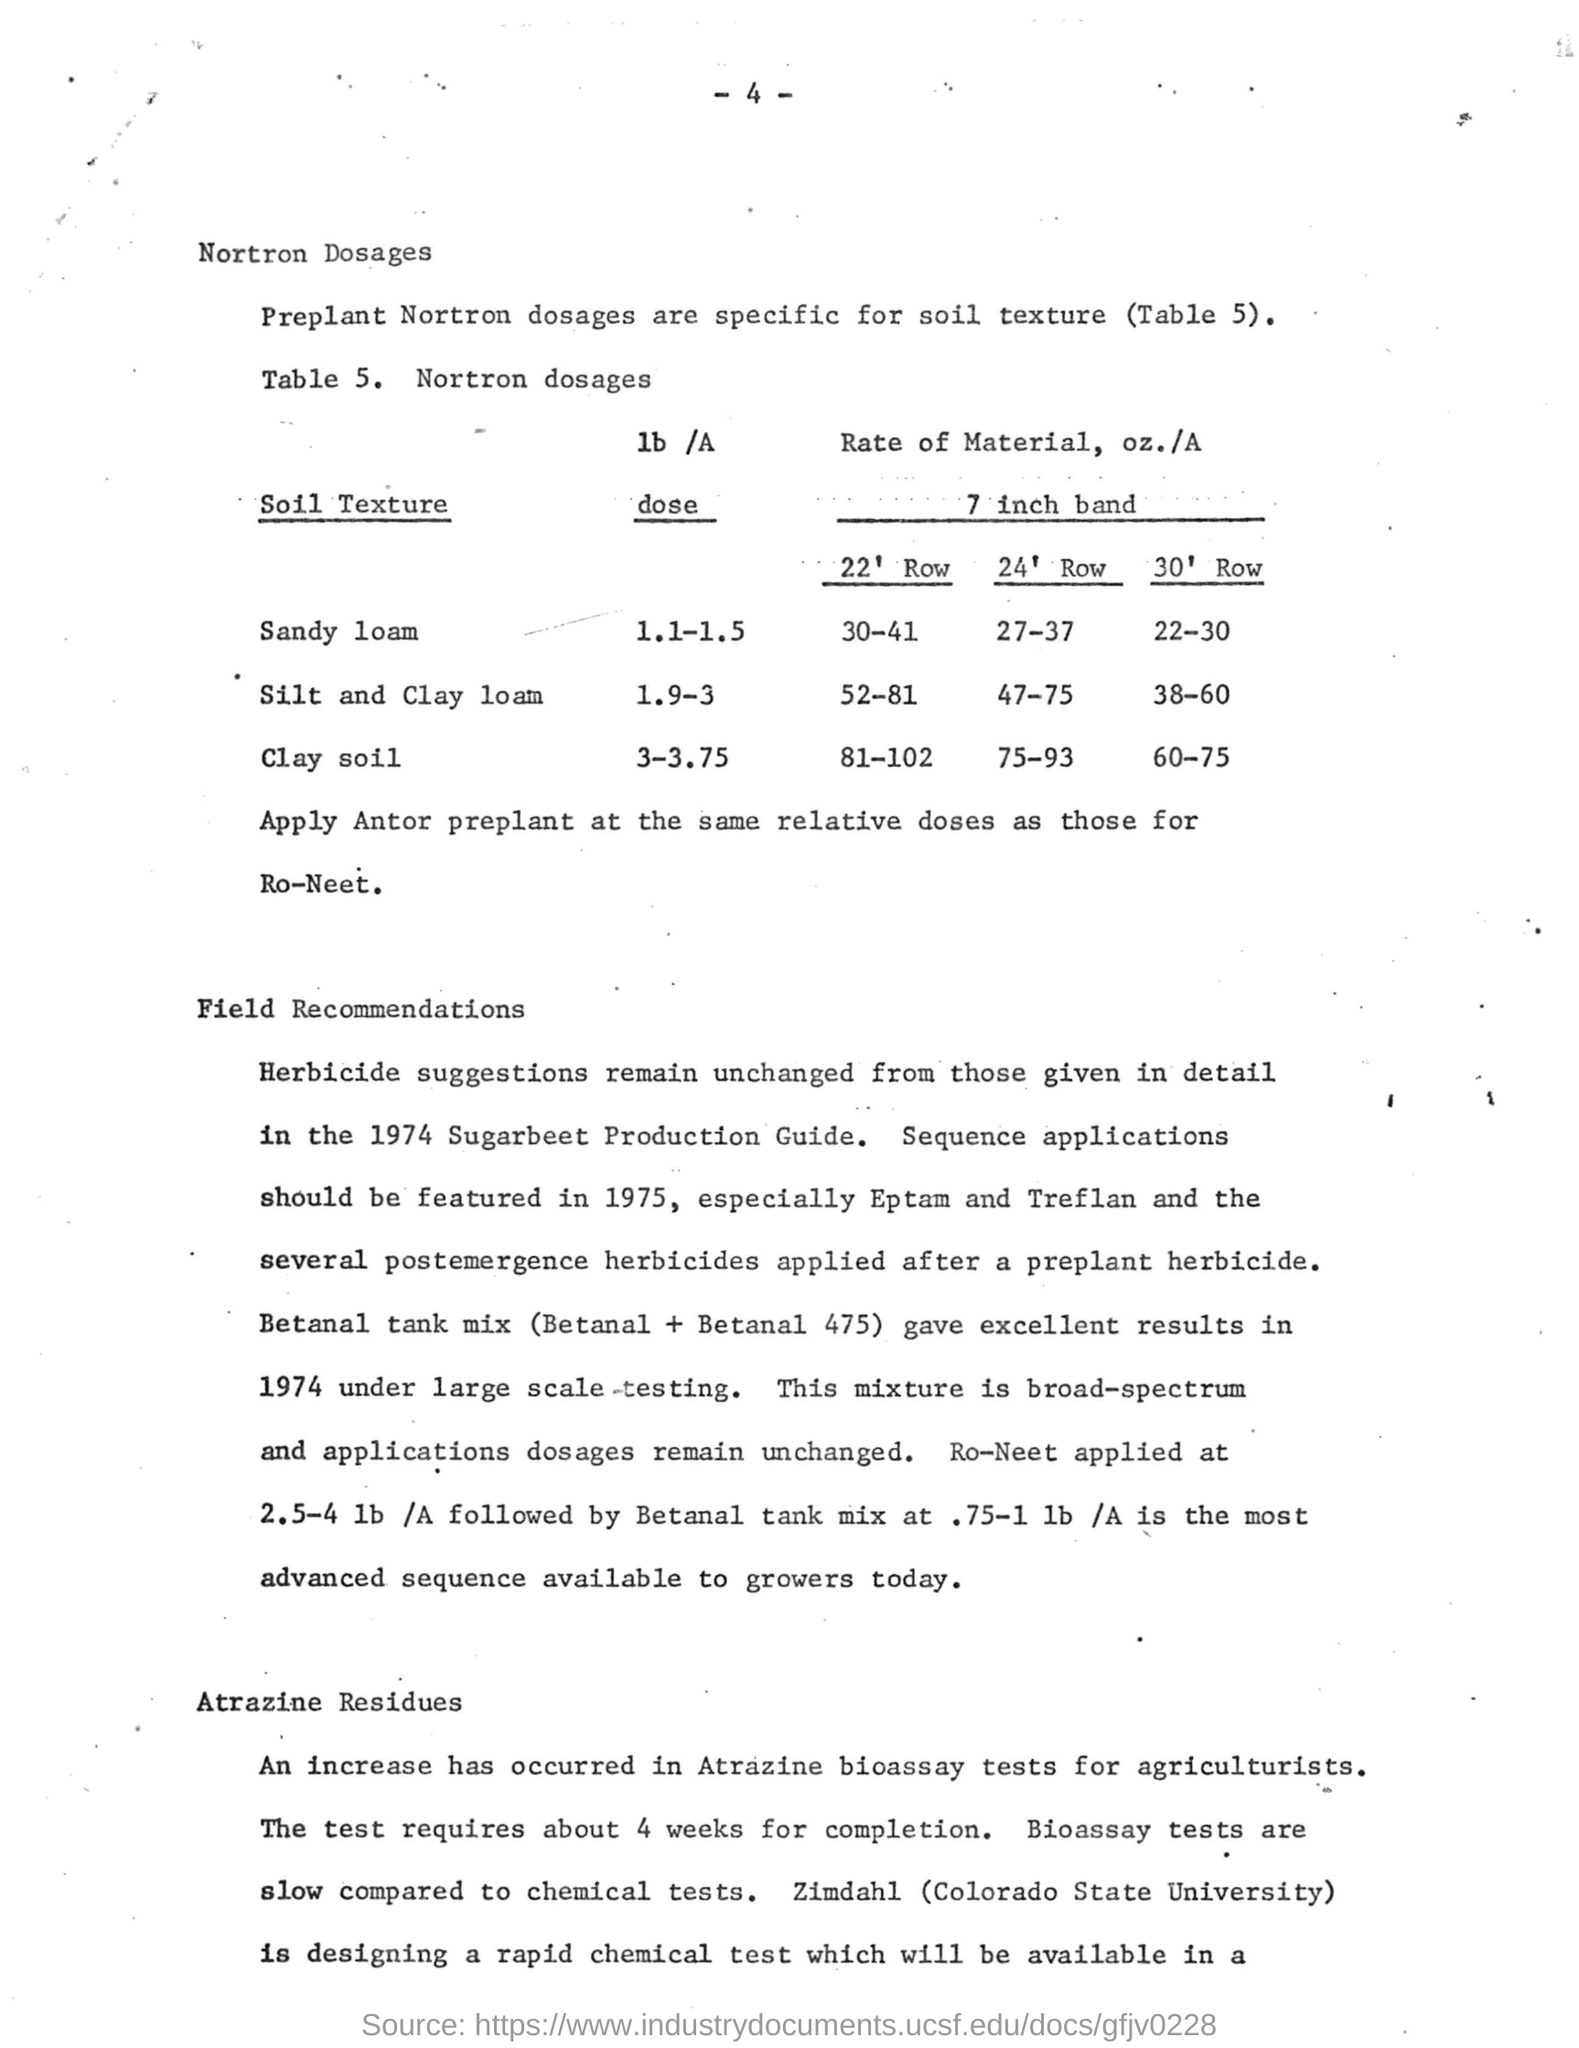Specify some key components in this picture. The recommended Nortron dose for Sandy loam soil ranges from 1.1 to 1.5 pounds per acre. The recommended Nortron dose for clay soil ranges from 3 to 3.75 pounds per acre, depending on the specific needs of the crop and the soil conditions. The rate of material for a 30-foot row in clay soil is 60-75 ounces per acre, depending on various factors. The rate of material, expressed in ounces per acre, for a 22-foot row in silt and clay loam soil is between 52 and 81, depending on the specific soil conditions. The soil texture that receives Nortron dosage ranging from 1.9 to 3 pounds per acre is silt and clay loam. 